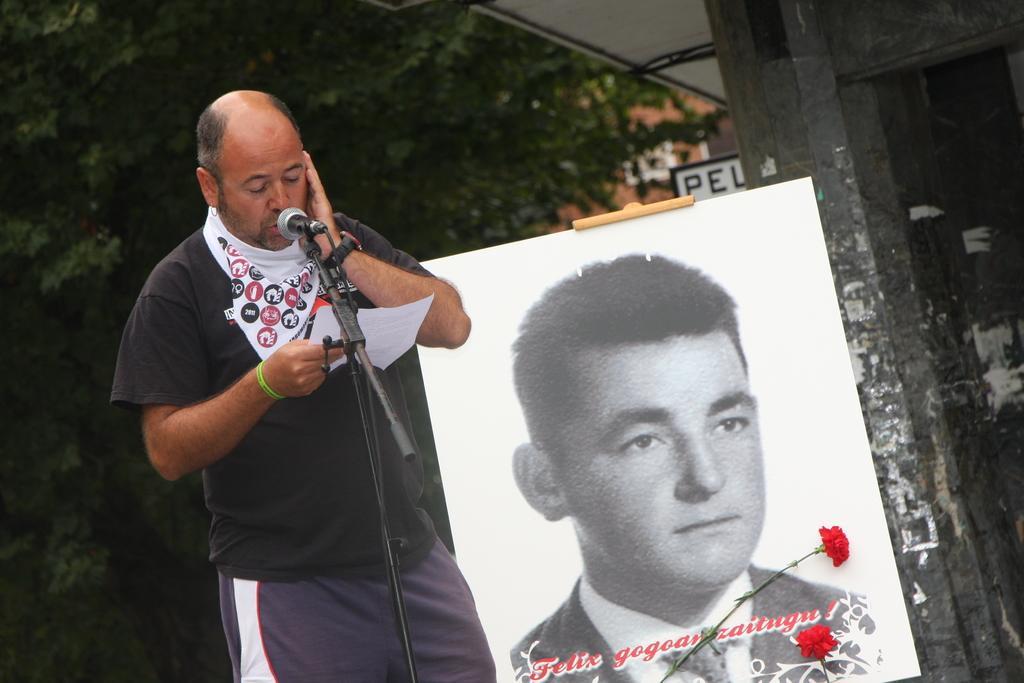Can you describe this image briefly? In the image there is a man on left side talking on mic with trees behind him and a black and white of a man with flower on right side of him, in the background it seems to be a building. 